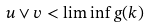<formula> <loc_0><loc_0><loc_500><loc_500>u \vee v < \liminf g ( k )</formula> 